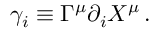Convert formula to latex. <formula><loc_0><loc_0><loc_500><loc_500>\gamma _ { i } \equiv \Gamma ^ { \mu } \partial _ { i } X ^ { \mu } \, .</formula> 